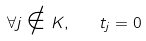<formula> <loc_0><loc_0><loc_500><loc_500>\forall j \notin K , \quad t _ { j } = 0</formula> 